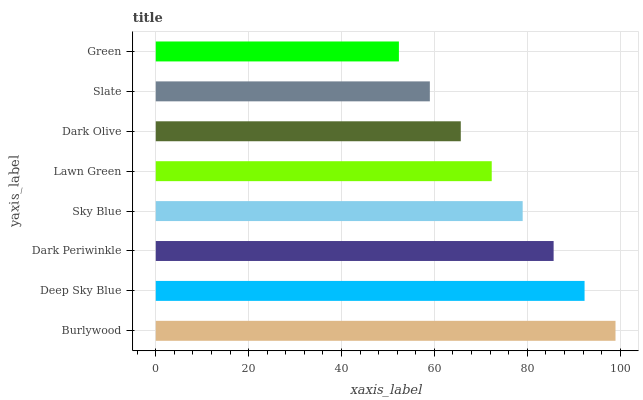Is Green the minimum?
Answer yes or no. Yes. Is Burlywood the maximum?
Answer yes or no. Yes. Is Deep Sky Blue the minimum?
Answer yes or no. No. Is Deep Sky Blue the maximum?
Answer yes or no. No. Is Burlywood greater than Deep Sky Blue?
Answer yes or no. Yes. Is Deep Sky Blue less than Burlywood?
Answer yes or no. Yes. Is Deep Sky Blue greater than Burlywood?
Answer yes or no. No. Is Burlywood less than Deep Sky Blue?
Answer yes or no. No. Is Sky Blue the high median?
Answer yes or no. Yes. Is Lawn Green the low median?
Answer yes or no. Yes. Is Dark Periwinkle the high median?
Answer yes or no. No. Is Sky Blue the low median?
Answer yes or no. No. 